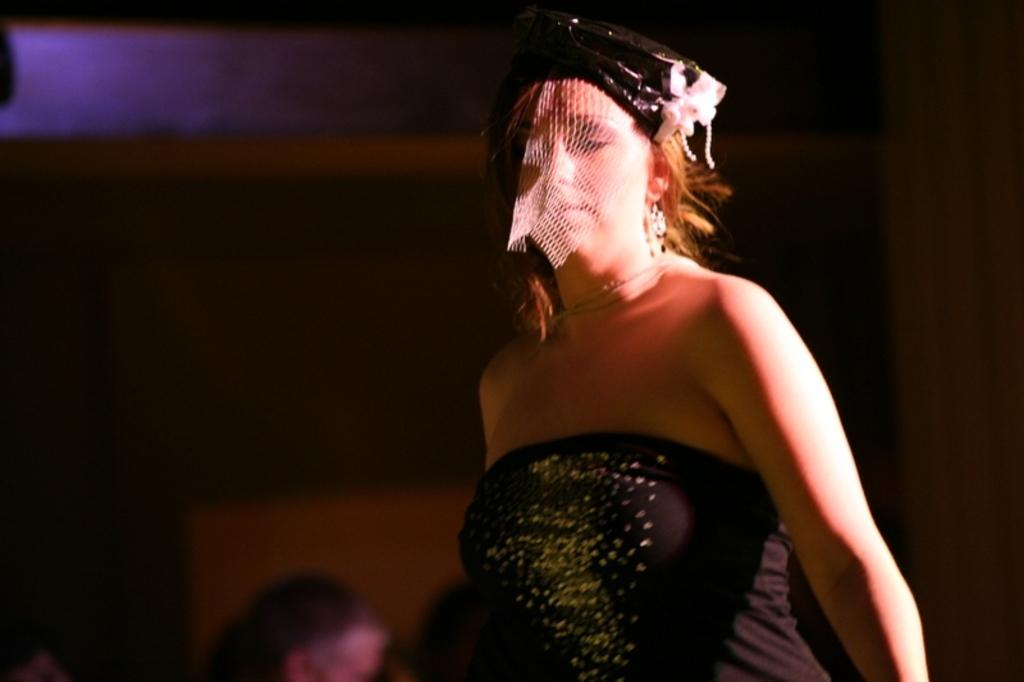Who is the main subject in the image? There is a lady in the image. What is the lady wearing on her head? The lady is wearing a cap. What is the lady wearing on her face? The lady is wearing a mask. What can be observed about the background of the image? The background of the image is dark. What type of calendar is hanging on the wall in the image? There is no calendar present in the image. What kind of attraction can be seen in the background of the image? There is no attraction visible in the image; the background is dark. 